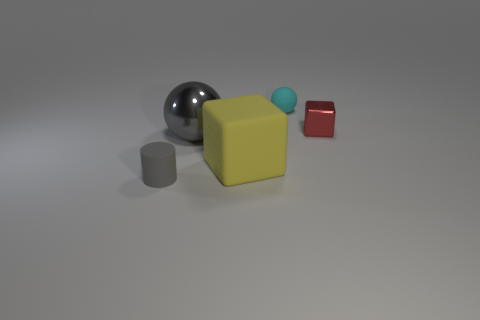Add 4 purple rubber cubes. How many objects exist? 9 Subtract all spheres. How many objects are left? 3 Add 2 tiny cyan balls. How many tiny cyan balls are left? 3 Add 2 rubber blocks. How many rubber blocks exist? 3 Subtract 0 brown balls. How many objects are left? 5 Subtract all shiny blocks. Subtract all small gray cylinders. How many objects are left? 3 